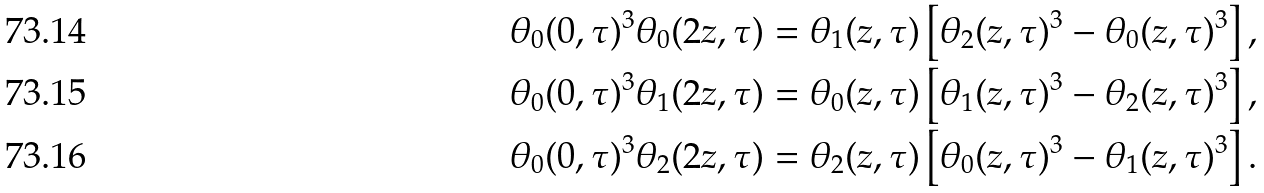Convert formula to latex. <formula><loc_0><loc_0><loc_500><loc_500>& \theta _ { 0 } ( 0 , \tau ) ^ { 3 } \theta _ { 0 } ( 2 z , \tau ) = \theta _ { 1 } ( z , \tau ) \left [ \theta _ { 2 } ( z , \tau ) ^ { 3 } - \theta _ { 0 } ( z , \tau ) ^ { 3 } \right ] , \\ & \theta _ { 0 } ( 0 , \tau ) ^ { 3 } \theta _ { 1 } ( 2 z , \tau ) = \theta _ { 0 } ( z , \tau ) \left [ \theta _ { 1 } ( z , \tau ) ^ { 3 } - \theta _ { 2 } ( z , \tau ) ^ { 3 } \right ] , \\ & \theta _ { 0 } ( 0 , \tau ) ^ { 3 } \theta _ { 2 } ( 2 z , \tau ) = \theta _ { 2 } ( z , \tau ) \left [ \theta _ { 0 } ( z , \tau ) ^ { 3 } - \theta _ { 1 } ( z , \tau ) ^ { 3 } \right ] .</formula> 